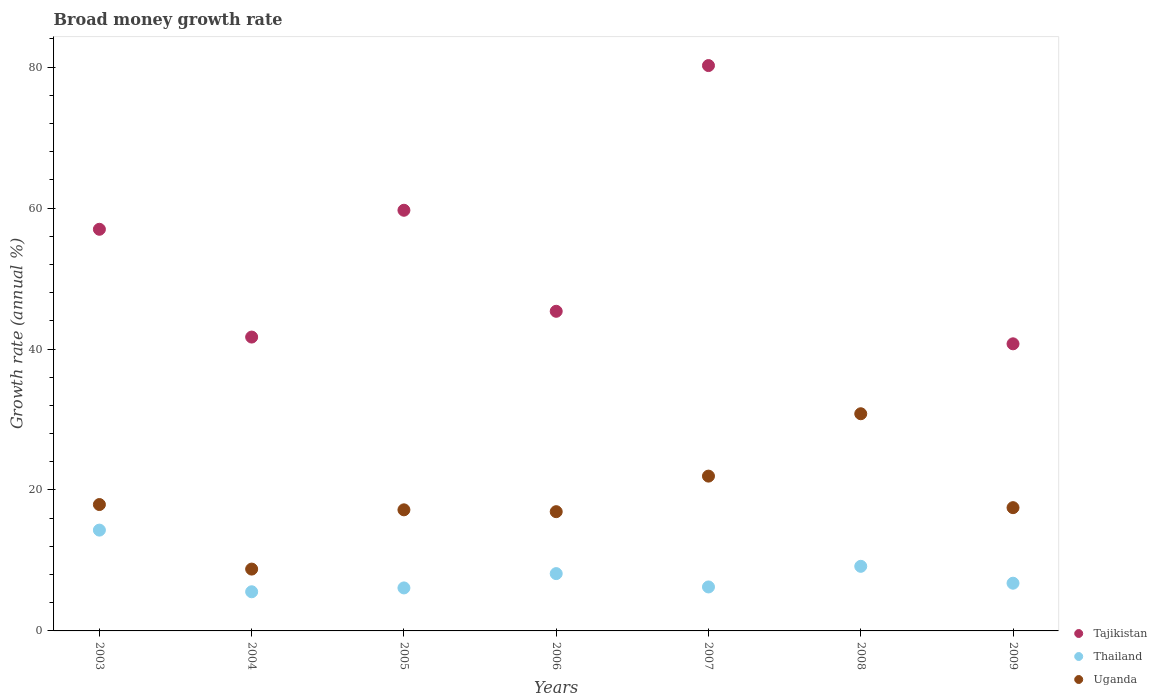How many different coloured dotlines are there?
Provide a short and direct response. 3. Is the number of dotlines equal to the number of legend labels?
Offer a very short reply. No. What is the growth rate in Thailand in 2004?
Offer a very short reply. 5.56. Across all years, what is the maximum growth rate in Uganda?
Provide a short and direct response. 30.82. Across all years, what is the minimum growth rate in Thailand?
Ensure brevity in your answer.  5.56. What is the total growth rate in Uganda in the graph?
Your answer should be very brief. 131.08. What is the difference between the growth rate in Thailand in 2004 and that in 2006?
Ensure brevity in your answer.  -2.58. What is the difference between the growth rate in Tajikistan in 2004 and the growth rate in Uganda in 2007?
Offer a terse response. 19.73. What is the average growth rate in Thailand per year?
Give a very brief answer. 8.04. In the year 2007, what is the difference between the growth rate in Thailand and growth rate in Uganda?
Provide a short and direct response. -15.73. In how many years, is the growth rate in Thailand greater than 48 %?
Offer a very short reply. 0. What is the ratio of the growth rate in Tajikistan in 2003 to that in 2007?
Make the answer very short. 0.71. What is the difference between the highest and the second highest growth rate in Tajikistan?
Make the answer very short. 20.53. What is the difference between the highest and the lowest growth rate in Thailand?
Offer a very short reply. 8.75. In how many years, is the growth rate in Uganda greater than the average growth rate in Uganda taken over all years?
Your answer should be very brief. 2. Is the sum of the growth rate in Thailand in 2005 and 2006 greater than the maximum growth rate in Tajikistan across all years?
Your answer should be compact. No. Does the growth rate in Tajikistan monotonically increase over the years?
Ensure brevity in your answer.  No. Is the growth rate in Uganda strictly less than the growth rate in Thailand over the years?
Your answer should be very brief. No. How many dotlines are there?
Your response must be concise. 3. How many years are there in the graph?
Your response must be concise. 7. What is the difference between two consecutive major ticks on the Y-axis?
Your answer should be compact. 20. Are the values on the major ticks of Y-axis written in scientific E-notation?
Make the answer very short. No. Does the graph contain any zero values?
Provide a short and direct response. Yes. Does the graph contain grids?
Your response must be concise. No. Where does the legend appear in the graph?
Provide a succinct answer. Bottom right. How many legend labels are there?
Provide a succinct answer. 3. What is the title of the graph?
Give a very brief answer. Broad money growth rate. What is the label or title of the X-axis?
Offer a very short reply. Years. What is the label or title of the Y-axis?
Ensure brevity in your answer.  Growth rate (annual %). What is the Growth rate (annual %) in Tajikistan in 2003?
Keep it short and to the point. 56.99. What is the Growth rate (annual %) in Thailand in 2003?
Your answer should be very brief. 14.3. What is the Growth rate (annual %) in Uganda in 2003?
Make the answer very short. 17.93. What is the Growth rate (annual %) of Tajikistan in 2004?
Make the answer very short. 41.7. What is the Growth rate (annual %) in Thailand in 2004?
Offer a terse response. 5.56. What is the Growth rate (annual %) in Uganda in 2004?
Your response must be concise. 8.77. What is the Growth rate (annual %) in Tajikistan in 2005?
Your answer should be compact. 59.69. What is the Growth rate (annual %) in Thailand in 2005?
Your answer should be compact. 6.1. What is the Growth rate (annual %) in Uganda in 2005?
Your answer should be very brief. 17.18. What is the Growth rate (annual %) in Tajikistan in 2006?
Give a very brief answer. 45.35. What is the Growth rate (annual %) in Thailand in 2006?
Your answer should be very brief. 8.13. What is the Growth rate (annual %) of Uganda in 2006?
Offer a terse response. 16.92. What is the Growth rate (annual %) of Tajikistan in 2007?
Your answer should be compact. 80.22. What is the Growth rate (annual %) of Thailand in 2007?
Provide a short and direct response. 6.24. What is the Growth rate (annual %) of Uganda in 2007?
Your answer should be very brief. 21.97. What is the Growth rate (annual %) of Tajikistan in 2008?
Keep it short and to the point. 0. What is the Growth rate (annual %) of Thailand in 2008?
Give a very brief answer. 9.17. What is the Growth rate (annual %) in Uganda in 2008?
Offer a terse response. 30.82. What is the Growth rate (annual %) of Tajikistan in 2009?
Your answer should be very brief. 40.74. What is the Growth rate (annual %) of Thailand in 2009?
Keep it short and to the point. 6.77. What is the Growth rate (annual %) in Uganda in 2009?
Keep it short and to the point. 17.49. Across all years, what is the maximum Growth rate (annual %) of Tajikistan?
Your answer should be very brief. 80.22. Across all years, what is the maximum Growth rate (annual %) in Thailand?
Keep it short and to the point. 14.3. Across all years, what is the maximum Growth rate (annual %) of Uganda?
Your response must be concise. 30.82. Across all years, what is the minimum Growth rate (annual %) of Thailand?
Ensure brevity in your answer.  5.56. Across all years, what is the minimum Growth rate (annual %) of Uganda?
Ensure brevity in your answer.  8.77. What is the total Growth rate (annual %) in Tajikistan in the graph?
Keep it short and to the point. 324.7. What is the total Growth rate (annual %) of Thailand in the graph?
Your response must be concise. 56.27. What is the total Growth rate (annual %) of Uganda in the graph?
Give a very brief answer. 131.08. What is the difference between the Growth rate (annual %) of Tajikistan in 2003 and that in 2004?
Your answer should be compact. 15.29. What is the difference between the Growth rate (annual %) in Thailand in 2003 and that in 2004?
Ensure brevity in your answer.  8.75. What is the difference between the Growth rate (annual %) of Uganda in 2003 and that in 2004?
Keep it short and to the point. 9.16. What is the difference between the Growth rate (annual %) in Tajikistan in 2003 and that in 2005?
Your answer should be compact. -2.7. What is the difference between the Growth rate (annual %) in Thailand in 2003 and that in 2005?
Keep it short and to the point. 8.2. What is the difference between the Growth rate (annual %) in Tajikistan in 2003 and that in 2006?
Offer a terse response. 11.64. What is the difference between the Growth rate (annual %) of Thailand in 2003 and that in 2006?
Make the answer very short. 6.17. What is the difference between the Growth rate (annual %) in Uganda in 2003 and that in 2006?
Offer a terse response. 1.01. What is the difference between the Growth rate (annual %) of Tajikistan in 2003 and that in 2007?
Your answer should be very brief. -23.23. What is the difference between the Growth rate (annual %) in Thailand in 2003 and that in 2007?
Give a very brief answer. 8.06. What is the difference between the Growth rate (annual %) in Uganda in 2003 and that in 2007?
Offer a terse response. -4.03. What is the difference between the Growth rate (annual %) in Thailand in 2003 and that in 2008?
Offer a very short reply. 5.14. What is the difference between the Growth rate (annual %) of Uganda in 2003 and that in 2008?
Your response must be concise. -12.88. What is the difference between the Growth rate (annual %) in Tajikistan in 2003 and that in 2009?
Keep it short and to the point. 16.25. What is the difference between the Growth rate (annual %) of Thailand in 2003 and that in 2009?
Offer a terse response. 7.53. What is the difference between the Growth rate (annual %) of Uganda in 2003 and that in 2009?
Offer a very short reply. 0.44. What is the difference between the Growth rate (annual %) of Tajikistan in 2004 and that in 2005?
Your answer should be very brief. -17.99. What is the difference between the Growth rate (annual %) in Thailand in 2004 and that in 2005?
Offer a very short reply. -0.55. What is the difference between the Growth rate (annual %) in Uganda in 2004 and that in 2005?
Give a very brief answer. -8.41. What is the difference between the Growth rate (annual %) of Tajikistan in 2004 and that in 2006?
Keep it short and to the point. -3.66. What is the difference between the Growth rate (annual %) of Thailand in 2004 and that in 2006?
Keep it short and to the point. -2.58. What is the difference between the Growth rate (annual %) of Uganda in 2004 and that in 2006?
Provide a short and direct response. -8.15. What is the difference between the Growth rate (annual %) of Tajikistan in 2004 and that in 2007?
Keep it short and to the point. -38.52. What is the difference between the Growth rate (annual %) in Thailand in 2004 and that in 2007?
Your response must be concise. -0.68. What is the difference between the Growth rate (annual %) of Uganda in 2004 and that in 2007?
Provide a short and direct response. -13.19. What is the difference between the Growth rate (annual %) of Thailand in 2004 and that in 2008?
Your answer should be very brief. -3.61. What is the difference between the Growth rate (annual %) of Uganda in 2004 and that in 2008?
Your answer should be very brief. -22.04. What is the difference between the Growth rate (annual %) of Tajikistan in 2004 and that in 2009?
Offer a terse response. 0.96. What is the difference between the Growth rate (annual %) of Thailand in 2004 and that in 2009?
Give a very brief answer. -1.22. What is the difference between the Growth rate (annual %) in Uganda in 2004 and that in 2009?
Offer a terse response. -8.72. What is the difference between the Growth rate (annual %) of Tajikistan in 2005 and that in 2006?
Provide a succinct answer. 14.34. What is the difference between the Growth rate (annual %) in Thailand in 2005 and that in 2006?
Ensure brevity in your answer.  -2.03. What is the difference between the Growth rate (annual %) of Uganda in 2005 and that in 2006?
Your response must be concise. 0.26. What is the difference between the Growth rate (annual %) in Tajikistan in 2005 and that in 2007?
Your answer should be very brief. -20.53. What is the difference between the Growth rate (annual %) of Thailand in 2005 and that in 2007?
Your answer should be compact. -0.14. What is the difference between the Growth rate (annual %) in Uganda in 2005 and that in 2007?
Offer a very short reply. -4.78. What is the difference between the Growth rate (annual %) of Thailand in 2005 and that in 2008?
Your answer should be compact. -3.07. What is the difference between the Growth rate (annual %) of Uganda in 2005 and that in 2008?
Provide a succinct answer. -13.63. What is the difference between the Growth rate (annual %) in Tajikistan in 2005 and that in 2009?
Ensure brevity in your answer.  18.95. What is the difference between the Growth rate (annual %) of Thailand in 2005 and that in 2009?
Offer a terse response. -0.67. What is the difference between the Growth rate (annual %) of Uganda in 2005 and that in 2009?
Keep it short and to the point. -0.31. What is the difference between the Growth rate (annual %) of Tajikistan in 2006 and that in 2007?
Keep it short and to the point. -34.87. What is the difference between the Growth rate (annual %) of Thailand in 2006 and that in 2007?
Offer a very short reply. 1.89. What is the difference between the Growth rate (annual %) in Uganda in 2006 and that in 2007?
Your answer should be compact. -5.05. What is the difference between the Growth rate (annual %) of Thailand in 2006 and that in 2008?
Your response must be concise. -1.03. What is the difference between the Growth rate (annual %) in Uganda in 2006 and that in 2008?
Give a very brief answer. -13.9. What is the difference between the Growth rate (annual %) of Tajikistan in 2006 and that in 2009?
Give a very brief answer. 4.62. What is the difference between the Growth rate (annual %) in Thailand in 2006 and that in 2009?
Your answer should be very brief. 1.36. What is the difference between the Growth rate (annual %) in Uganda in 2006 and that in 2009?
Offer a very short reply. -0.57. What is the difference between the Growth rate (annual %) in Thailand in 2007 and that in 2008?
Keep it short and to the point. -2.93. What is the difference between the Growth rate (annual %) of Uganda in 2007 and that in 2008?
Provide a short and direct response. -8.85. What is the difference between the Growth rate (annual %) of Tajikistan in 2007 and that in 2009?
Your answer should be compact. 39.48. What is the difference between the Growth rate (annual %) in Thailand in 2007 and that in 2009?
Provide a succinct answer. -0.53. What is the difference between the Growth rate (annual %) of Uganda in 2007 and that in 2009?
Keep it short and to the point. 4.48. What is the difference between the Growth rate (annual %) of Thailand in 2008 and that in 2009?
Your answer should be compact. 2.4. What is the difference between the Growth rate (annual %) in Uganda in 2008 and that in 2009?
Ensure brevity in your answer.  13.33. What is the difference between the Growth rate (annual %) in Tajikistan in 2003 and the Growth rate (annual %) in Thailand in 2004?
Ensure brevity in your answer.  51.44. What is the difference between the Growth rate (annual %) of Tajikistan in 2003 and the Growth rate (annual %) of Uganda in 2004?
Your answer should be very brief. 48.22. What is the difference between the Growth rate (annual %) of Thailand in 2003 and the Growth rate (annual %) of Uganda in 2004?
Your response must be concise. 5.53. What is the difference between the Growth rate (annual %) of Tajikistan in 2003 and the Growth rate (annual %) of Thailand in 2005?
Your answer should be very brief. 50.89. What is the difference between the Growth rate (annual %) in Tajikistan in 2003 and the Growth rate (annual %) in Uganda in 2005?
Provide a short and direct response. 39.81. What is the difference between the Growth rate (annual %) of Thailand in 2003 and the Growth rate (annual %) of Uganda in 2005?
Ensure brevity in your answer.  -2.88. What is the difference between the Growth rate (annual %) in Tajikistan in 2003 and the Growth rate (annual %) in Thailand in 2006?
Offer a terse response. 48.86. What is the difference between the Growth rate (annual %) of Tajikistan in 2003 and the Growth rate (annual %) of Uganda in 2006?
Ensure brevity in your answer.  40.07. What is the difference between the Growth rate (annual %) in Thailand in 2003 and the Growth rate (annual %) in Uganda in 2006?
Your answer should be very brief. -2.62. What is the difference between the Growth rate (annual %) in Tajikistan in 2003 and the Growth rate (annual %) in Thailand in 2007?
Give a very brief answer. 50.75. What is the difference between the Growth rate (annual %) of Tajikistan in 2003 and the Growth rate (annual %) of Uganda in 2007?
Offer a terse response. 35.03. What is the difference between the Growth rate (annual %) of Thailand in 2003 and the Growth rate (annual %) of Uganda in 2007?
Offer a very short reply. -7.66. What is the difference between the Growth rate (annual %) of Tajikistan in 2003 and the Growth rate (annual %) of Thailand in 2008?
Give a very brief answer. 47.82. What is the difference between the Growth rate (annual %) of Tajikistan in 2003 and the Growth rate (annual %) of Uganda in 2008?
Provide a short and direct response. 26.18. What is the difference between the Growth rate (annual %) in Thailand in 2003 and the Growth rate (annual %) in Uganda in 2008?
Ensure brevity in your answer.  -16.51. What is the difference between the Growth rate (annual %) in Tajikistan in 2003 and the Growth rate (annual %) in Thailand in 2009?
Your answer should be very brief. 50.22. What is the difference between the Growth rate (annual %) of Tajikistan in 2003 and the Growth rate (annual %) of Uganda in 2009?
Keep it short and to the point. 39.5. What is the difference between the Growth rate (annual %) of Thailand in 2003 and the Growth rate (annual %) of Uganda in 2009?
Your answer should be compact. -3.19. What is the difference between the Growth rate (annual %) in Tajikistan in 2004 and the Growth rate (annual %) in Thailand in 2005?
Keep it short and to the point. 35.6. What is the difference between the Growth rate (annual %) in Tajikistan in 2004 and the Growth rate (annual %) in Uganda in 2005?
Offer a terse response. 24.51. What is the difference between the Growth rate (annual %) of Thailand in 2004 and the Growth rate (annual %) of Uganda in 2005?
Offer a terse response. -11.63. What is the difference between the Growth rate (annual %) in Tajikistan in 2004 and the Growth rate (annual %) in Thailand in 2006?
Offer a terse response. 33.56. What is the difference between the Growth rate (annual %) in Tajikistan in 2004 and the Growth rate (annual %) in Uganda in 2006?
Your answer should be compact. 24.78. What is the difference between the Growth rate (annual %) in Thailand in 2004 and the Growth rate (annual %) in Uganda in 2006?
Your response must be concise. -11.37. What is the difference between the Growth rate (annual %) of Tajikistan in 2004 and the Growth rate (annual %) of Thailand in 2007?
Your response must be concise. 35.46. What is the difference between the Growth rate (annual %) in Tajikistan in 2004 and the Growth rate (annual %) in Uganda in 2007?
Provide a succinct answer. 19.73. What is the difference between the Growth rate (annual %) of Thailand in 2004 and the Growth rate (annual %) of Uganda in 2007?
Keep it short and to the point. -16.41. What is the difference between the Growth rate (annual %) in Tajikistan in 2004 and the Growth rate (annual %) in Thailand in 2008?
Offer a very short reply. 32.53. What is the difference between the Growth rate (annual %) of Tajikistan in 2004 and the Growth rate (annual %) of Uganda in 2008?
Your answer should be compact. 10.88. What is the difference between the Growth rate (annual %) in Thailand in 2004 and the Growth rate (annual %) in Uganda in 2008?
Offer a terse response. -25.26. What is the difference between the Growth rate (annual %) in Tajikistan in 2004 and the Growth rate (annual %) in Thailand in 2009?
Keep it short and to the point. 34.93. What is the difference between the Growth rate (annual %) in Tajikistan in 2004 and the Growth rate (annual %) in Uganda in 2009?
Your response must be concise. 24.21. What is the difference between the Growth rate (annual %) in Thailand in 2004 and the Growth rate (annual %) in Uganda in 2009?
Provide a succinct answer. -11.94. What is the difference between the Growth rate (annual %) in Tajikistan in 2005 and the Growth rate (annual %) in Thailand in 2006?
Your answer should be very brief. 51.56. What is the difference between the Growth rate (annual %) in Tajikistan in 2005 and the Growth rate (annual %) in Uganda in 2006?
Give a very brief answer. 42.77. What is the difference between the Growth rate (annual %) of Thailand in 2005 and the Growth rate (annual %) of Uganda in 2006?
Your response must be concise. -10.82. What is the difference between the Growth rate (annual %) of Tajikistan in 2005 and the Growth rate (annual %) of Thailand in 2007?
Your answer should be compact. 53.45. What is the difference between the Growth rate (annual %) in Tajikistan in 2005 and the Growth rate (annual %) in Uganda in 2007?
Your response must be concise. 37.72. What is the difference between the Growth rate (annual %) of Thailand in 2005 and the Growth rate (annual %) of Uganda in 2007?
Give a very brief answer. -15.86. What is the difference between the Growth rate (annual %) of Tajikistan in 2005 and the Growth rate (annual %) of Thailand in 2008?
Offer a terse response. 50.52. What is the difference between the Growth rate (annual %) in Tajikistan in 2005 and the Growth rate (annual %) in Uganda in 2008?
Provide a short and direct response. 28.87. What is the difference between the Growth rate (annual %) in Thailand in 2005 and the Growth rate (annual %) in Uganda in 2008?
Provide a short and direct response. -24.71. What is the difference between the Growth rate (annual %) in Tajikistan in 2005 and the Growth rate (annual %) in Thailand in 2009?
Provide a succinct answer. 52.92. What is the difference between the Growth rate (annual %) in Tajikistan in 2005 and the Growth rate (annual %) in Uganda in 2009?
Your answer should be very brief. 42.2. What is the difference between the Growth rate (annual %) in Thailand in 2005 and the Growth rate (annual %) in Uganda in 2009?
Your answer should be compact. -11.39. What is the difference between the Growth rate (annual %) of Tajikistan in 2006 and the Growth rate (annual %) of Thailand in 2007?
Provide a succinct answer. 39.12. What is the difference between the Growth rate (annual %) of Tajikistan in 2006 and the Growth rate (annual %) of Uganda in 2007?
Provide a short and direct response. 23.39. What is the difference between the Growth rate (annual %) of Thailand in 2006 and the Growth rate (annual %) of Uganda in 2007?
Make the answer very short. -13.83. What is the difference between the Growth rate (annual %) of Tajikistan in 2006 and the Growth rate (annual %) of Thailand in 2008?
Your response must be concise. 36.19. What is the difference between the Growth rate (annual %) of Tajikistan in 2006 and the Growth rate (annual %) of Uganda in 2008?
Your answer should be very brief. 14.54. What is the difference between the Growth rate (annual %) of Thailand in 2006 and the Growth rate (annual %) of Uganda in 2008?
Keep it short and to the point. -22.68. What is the difference between the Growth rate (annual %) of Tajikistan in 2006 and the Growth rate (annual %) of Thailand in 2009?
Offer a terse response. 38.58. What is the difference between the Growth rate (annual %) of Tajikistan in 2006 and the Growth rate (annual %) of Uganda in 2009?
Give a very brief answer. 27.86. What is the difference between the Growth rate (annual %) in Thailand in 2006 and the Growth rate (annual %) in Uganda in 2009?
Give a very brief answer. -9.36. What is the difference between the Growth rate (annual %) in Tajikistan in 2007 and the Growth rate (annual %) in Thailand in 2008?
Offer a terse response. 71.06. What is the difference between the Growth rate (annual %) of Tajikistan in 2007 and the Growth rate (annual %) of Uganda in 2008?
Make the answer very short. 49.41. What is the difference between the Growth rate (annual %) of Thailand in 2007 and the Growth rate (annual %) of Uganda in 2008?
Your response must be concise. -24.58. What is the difference between the Growth rate (annual %) in Tajikistan in 2007 and the Growth rate (annual %) in Thailand in 2009?
Give a very brief answer. 73.45. What is the difference between the Growth rate (annual %) of Tajikistan in 2007 and the Growth rate (annual %) of Uganda in 2009?
Offer a terse response. 62.73. What is the difference between the Growth rate (annual %) of Thailand in 2007 and the Growth rate (annual %) of Uganda in 2009?
Provide a succinct answer. -11.25. What is the difference between the Growth rate (annual %) of Thailand in 2008 and the Growth rate (annual %) of Uganda in 2009?
Keep it short and to the point. -8.32. What is the average Growth rate (annual %) in Tajikistan per year?
Provide a short and direct response. 46.39. What is the average Growth rate (annual %) of Thailand per year?
Offer a very short reply. 8.04. What is the average Growth rate (annual %) of Uganda per year?
Keep it short and to the point. 18.73. In the year 2003, what is the difference between the Growth rate (annual %) of Tajikistan and Growth rate (annual %) of Thailand?
Your answer should be compact. 42.69. In the year 2003, what is the difference between the Growth rate (annual %) in Tajikistan and Growth rate (annual %) in Uganda?
Give a very brief answer. 39.06. In the year 2003, what is the difference between the Growth rate (annual %) in Thailand and Growth rate (annual %) in Uganda?
Your response must be concise. -3.63. In the year 2004, what is the difference between the Growth rate (annual %) of Tajikistan and Growth rate (annual %) of Thailand?
Ensure brevity in your answer.  36.14. In the year 2004, what is the difference between the Growth rate (annual %) of Tajikistan and Growth rate (annual %) of Uganda?
Your answer should be very brief. 32.92. In the year 2004, what is the difference between the Growth rate (annual %) in Thailand and Growth rate (annual %) in Uganda?
Provide a succinct answer. -3.22. In the year 2005, what is the difference between the Growth rate (annual %) in Tajikistan and Growth rate (annual %) in Thailand?
Offer a terse response. 53.59. In the year 2005, what is the difference between the Growth rate (annual %) in Tajikistan and Growth rate (annual %) in Uganda?
Ensure brevity in your answer.  42.51. In the year 2005, what is the difference between the Growth rate (annual %) of Thailand and Growth rate (annual %) of Uganda?
Provide a short and direct response. -11.08. In the year 2006, what is the difference between the Growth rate (annual %) in Tajikistan and Growth rate (annual %) in Thailand?
Offer a very short reply. 37.22. In the year 2006, what is the difference between the Growth rate (annual %) in Tajikistan and Growth rate (annual %) in Uganda?
Provide a succinct answer. 28.43. In the year 2006, what is the difference between the Growth rate (annual %) of Thailand and Growth rate (annual %) of Uganda?
Your answer should be very brief. -8.79. In the year 2007, what is the difference between the Growth rate (annual %) in Tajikistan and Growth rate (annual %) in Thailand?
Your answer should be compact. 73.98. In the year 2007, what is the difference between the Growth rate (annual %) of Tajikistan and Growth rate (annual %) of Uganda?
Make the answer very short. 58.26. In the year 2007, what is the difference between the Growth rate (annual %) in Thailand and Growth rate (annual %) in Uganda?
Your answer should be compact. -15.73. In the year 2008, what is the difference between the Growth rate (annual %) in Thailand and Growth rate (annual %) in Uganda?
Ensure brevity in your answer.  -21.65. In the year 2009, what is the difference between the Growth rate (annual %) in Tajikistan and Growth rate (annual %) in Thailand?
Ensure brevity in your answer.  33.97. In the year 2009, what is the difference between the Growth rate (annual %) of Tajikistan and Growth rate (annual %) of Uganda?
Give a very brief answer. 23.25. In the year 2009, what is the difference between the Growth rate (annual %) in Thailand and Growth rate (annual %) in Uganda?
Ensure brevity in your answer.  -10.72. What is the ratio of the Growth rate (annual %) in Tajikistan in 2003 to that in 2004?
Your response must be concise. 1.37. What is the ratio of the Growth rate (annual %) in Thailand in 2003 to that in 2004?
Ensure brevity in your answer.  2.57. What is the ratio of the Growth rate (annual %) of Uganda in 2003 to that in 2004?
Offer a very short reply. 2.04. What is the ratio of the Growth rate (annual %) of Tajikistan in 2003 to that in 2005?
Provide a succinct answer. 0.95. What is the ratio of the Growth rate (annual %) in Thailand in 2003 to that in 2005?
Provide a short and direct response. 2.34. What is the ratio of the Growth rate (annual %) in Uganda in 2003 to that in 2005?
Provide a short and direct response. 1.04. What is the ratio of the Growth rate (annual %) of Tajikistan in 2003 to that in 2006?
Provide a succinct answer. 1.26. What is the ratio of the Growth rate (annual %) in Thailand in 2003 to that in 2006?
Provide a short and direct response. 1.76. What is the ratio of the Growth rate (annual %) in Uganda in 2003 to that in 2006?
Your response must be concise. 1.06. What is the ratio of the Growth rate (annual %) of Tajikistan in 2003 to that in 2007?
Offer a very short reply. 0.71. What is the ratio of the Growth rate (annual %) of Thailand in 2003 to that in 2007?
Give a very brief answer. 2.29. What is the ratio of the Growth rate (annual %) of Uganda in 2003 to that in 2007?
Offer a very short reply. 0.82. What is the ratio of the Growth rate (annual %) in Thailand in 2003 to that in 2008?
Give a very brief answer. 1.56. What is the ratio of the Growth rate (annual %) in Uganda in 2003 to that in 2008?
Keep it short and to the point. 0.58. What is the ratio of the Growth rate (annual %) in Tajikistan in 2003 to that in 2009?
Offer a terse response. 1.4. What is the ratio of the Growth rate (annual %) in Thailand in 2003 to that in 2009?
Ensure brevity in your answer.  2.11. What is the ratio of the Growth rate (annual %) of Uganda in 2003 to that in 2009?
Make the answer very short. 1.03. What is the ratio of the Growth rate (annual %) in Tajikistan in 2004 to that in 2005?
Give a very brief answer. 0.7. What is the ratio of the Growth rate (annual %) in Thailand in 2004 to that in 2005?
Provide a succinct answer. 0.91. What is the ratio of the Growth rate (annual %) in Uganda in 2004 to that in 2005?
Give a very brief answer. 0.51. What is the ratio of the Growth rate (annual %) in Tajikistan in 2004 to that in 2006?
Your answer should be very brief. 0.92. What is the ratio of the Growth rate (annual %) in Thailand in 2004 to that in 2006?
Make the answer very short. 0.68. What is the ratio of the Growth rate (annual %) in Uganda in 2004 to that in 2006?
Your response must be concise. 0.52. What is the ratio of the Growth rate (annual %) of Tajikistan in 2004 to that in 2007?
Offer a very short reply. 0.52. What is the ratio of the Growth rate (annual %) in Thailand in 2004 to that in 2007?
Provide a succinct answer. 0.89. What is the ratio of the Growth rate (annual %) of Uganda in 2004 to that in 2007?
Give a very brief answer. 0.4. What is the ratio of the Growth rate (annual %) in Thailand in 2004 to that in 2008?
Ensure brevity in your answer.  0.61. What is the ratio of the Growth rate (annual %) in Uganda in 2004 to that in 2008?
Give a very brief answer. 0.28. What is the ratio of the Growth rate (annual %) of Tajikistan in 2004 to that in 2009?
Offer a terse response. 1.02. What is the ratio of the Growth rate (annual %) of Thailand in 2004 to that in 2009?
Offer a very short reply. 0.82. What is the ratio of the Growth rate (annual %) of Uganda in 2004 to that in 2009?
Your answer should be compact. 0.5. What is the ratio of the Growth rate (annual %) of Tajikistan in 2005 to that in 2006?
Make the answer very short. 1.32. What is the ratio of the Growth rate (annual %) in Thailand in 2005 to that in 2006?
Your response must be concise. 0.75. What is the ratio of the Growth rate (annual %) of Uganda in 2005 to that in 2006?
Offer a terse response. 1.02. What is the ratio of the Growth rate (annual %) of Tajikistan in 2005 to that in 2007?
Your answer should be very brief. 0.74. What is the ratio of the Growth rate (annual %) in Thailand in 2005 to that in 2007?
Provide a succinct answer. 0.98. What is the ratio of the Growth rate (annual %) in Uganda in 2005 to that in 2007?
Give a very brief answer. 0.78. What is the ratio of the Growth rate (annual %) in Thailand in 2005 to that in 2008?
Give a very brief answer. 0.67. What is the ratio of the Growth rate (annual %) of Uganda in 2005 to that in 2008?
Ensure brevity in your answer.  0.56. What is the ratio of the Growth rate (annual %) of Tajikistan in 2005 to that in 2009?
Offer a very short reply. 1.47. What is the ratio of the Growth rate (annual %) in Thailand in 2005 to that in 2009?
Ensure brevity in your answer.  0.9. What is the ratio of the Growth rate (annual %) of Uganda in 2005 to that in 2009?
Keep it short and to the point. 0.98. What is the ratio of the Growth rate (annual %) of Tajikistan in 2006 to that in 2007?
Your response must be concise. 0.57. What is the ratio of the Growth rate (annual %) of Thailand in 2006 to that in 2007?
Offer a very short reply. 1.3. What is the ratio of the Growth rate (annual %) in Uganda in 2006 to that in 2007?
Ensure brevity in your answer.  0.77. What is the ratio of the Growth rate (annual %) in Thailand in 2006 to that in 2008?
Provide a short and direct response. 0.89. What is the ratio of the Growth rate (annual %) of Uganda in 2006 to that in 2008?
Make the answer very short. 0.55. What is the ratio of the Growth rate (annual %) in Tajikistan in 2006 to that in 2009?
Ensure brevity in your answer.  1.11. What is the ratio of the Growth rate (annual %) in Thailand in 2006 to that in 2009?
Make the answer very short. 1.2. What is the ratio of the Growth rate (annual %) in Uganda in 2006 to that in 2009?
Ensure brevity in your answer.  0.97. What is the ratio of the Growth rate (annual %) of Thailand in 2007 to that in 2008?
Offer a terse response. 0.68. What is the ratio of the Growth rate (annual %) in Uganda in 2007 to that in 2008?
Make the answer very short. 0.71. What is the ratio of the Growth rate (annual %) in Tajikistan in 2007 to that in 2009?
Your answer should be very brief. 1.97. What is the ratio of the Growth rate (annual %) of Thailand in 2007 to that in 2009?
Your answer should be compact. 0.92. What is the ratio of the Growth rate (annual %) in Uganda in 2007 to that in 2009?
Offer a very short reply. 1.26. What is the ratio of the Growth rate (annual %) in Thailand in 2008 to that in 2009?
Give a very brief answer. 1.35. What is the ratio of the Growth rate (annual %) in Uganda in 2008 to that in 2009?
Your answer should be compact. 1.76. What is the difference between the highest and the second highest Growth rate (annual %) in Tajikistan?
Give a very brief answer. 20.53. What is the difference between the highest and the second highest Growth rate (annual %) in Thailand?
Ensure brevity in your answer.  5.14. What is the difference between the highest and the second highest Growth rate (annual %) of Uganda?
Offer a very short reply. 8.85. What is the difference between the highest and the lowest Growth rate (annual %) of Tajikistan?
Give a very brief answer. 80.22. What is the difference between the highest and the lowest Growth rate (annual %) in Thailand?
Your answer should be compact. 8.75. What is the difference between the highest and the lowest Growth rate (annual %) of Uganda?
Your response must be concise. 22.04. 